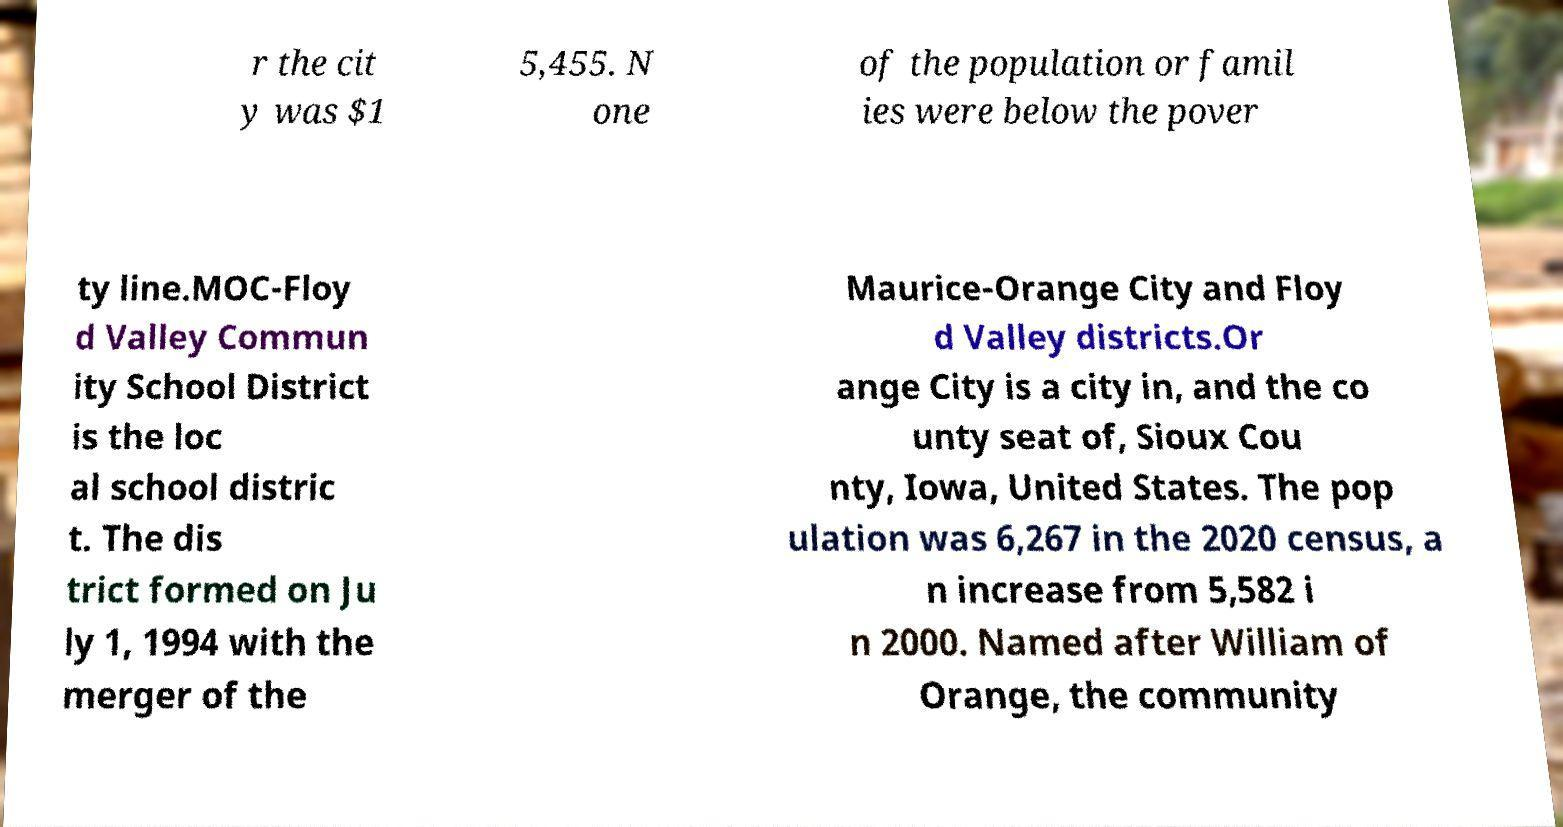Please identify and transcribe the text found in this image. r the cit y was $1 5,455. N one of the population or famil ies were below the pover ty line.MOC-Floy d Valley Commun ity School District is the loc al school distric t. The dis trict formed on Ju ly 1, 1994 with the merger of the Maurice-Orange City and Floy d Valley districts.Or ange City is a city in, and the co unty seat of, Sioux Cou nty, Iowa, United States. The pop ulation was 6,267 in the 2020 census, a n increase from 5,582 i n 2000. Named after William of Orange, the community 